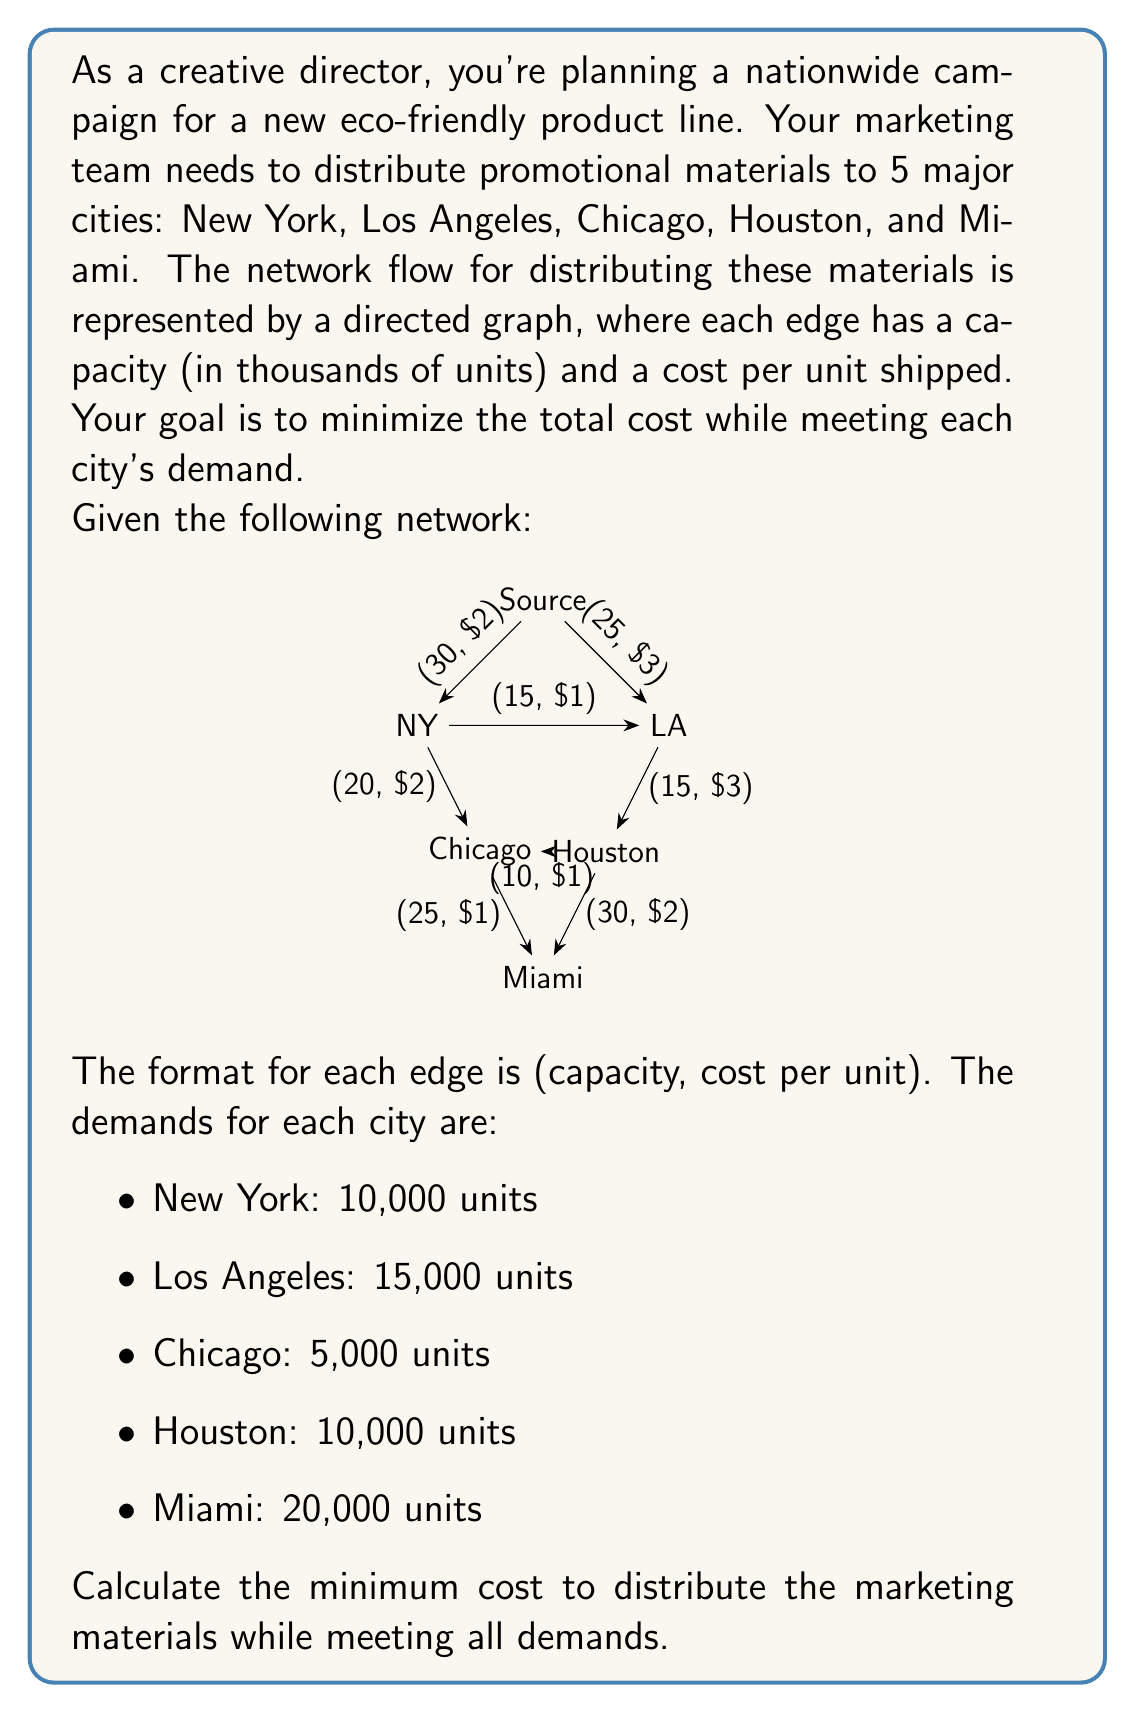Can you solve this math problem? To solve this problem, we'll use the minimum cost flow algorithm. Here's a step-by-step approach:

1) First, we need to ensure that the total supply meets the total demand:
   Total demand = 10 + 15 + 5 + 10 + 20 = 60 thousand units
   The source can supply up to 30 + 25 = 55 thousand units
   We need to add a dummy source with 5 thousand units capacity and $0 cost to balance the network.

2) We'll use the successive shortest path algorithm to find the minimum cost flow:

   a) Find the shortest path from source to Miami (sink):
      Source -> NY -> Chicago -> Miami (Cost: $2 + $2 + $1 = $5)
      Flow: min(30, 20, 25, 20) = 20
      Total cost: 20 * $5 = $100

   b) Update residual graph and find next shortest path:
      Source -> LA -> Houston -> Miami (Cost: $3 + $3 + $2 = $8)
      Flow: min(25, 15, 30, 10) = 10
      Total cost: 10 * $8 = $80

   c) Next shortest path:
      Source -> NY -> Chicago -> Houston -> Miami (Cost: $2 + $2 + $1 + $2 = $7)
      Flow: min(10, 10, 5, 10, 10) = 5
      Total cost: 5 * $7 = $35

   d) Next shortest path:
      Source -> NY -> LA -> Houston (Cost: $2 + $1 + $3 = $6)
      Flow: min(5, 5, 15, 10) = 5
      Total cost: 5 * $6 = $30

   e) Final flow from dummy source:
      Dummy -> NY -> LA (Cost: $0 + $2 + $1 = $3)
      Flow: 5
      Total cost: 5 * $3 = $15

3) Sum up the total cost: $100 + $80 + $35 + $30 + $15 = $260

4) Verify that all demands are met:
   NY: 20 + 5 + 5 = 30 (10 to Chicago, 5 to LA, 15 distributed)
   LA: 10 + 5 + 5 = 20 (15 distributed, 5 to Houston)
   Chicago: 20 + 5 = 25 (5 distributed, 20 to Miami)
   Houston: 10 + 5 + 5 = 20 (10 distributed, 10 to Miami)
   Miami: 20 + 10 + 10 = 40 (20 distributed)

Therefore, the minimum cost to distribute the marketing materials while meeting all demands is $260,000.
Answer: $260,000 